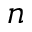Convert formula to latex. <formula><loc_0><loc_0><loc_500><loc_500>n</formula> 